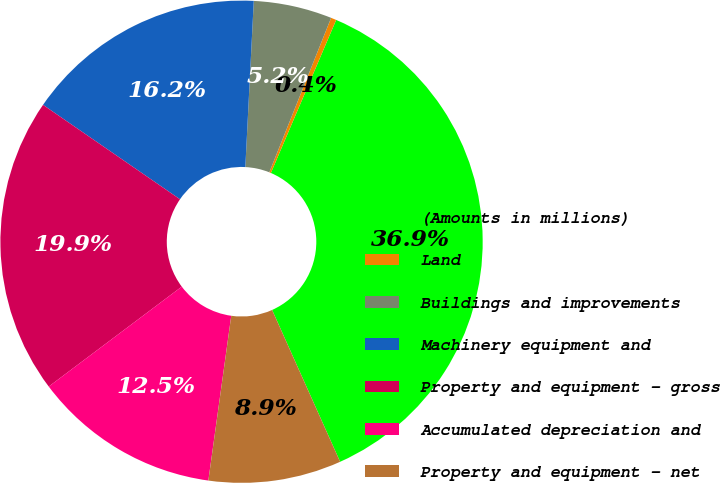Convert chart to OTSL. <chart><loc_0><loc_0><loc_500><loc_500><pie_chart><fcel>(Amounts in millions)<fcel>Land<fcel>Buildings and improvements<fcel>Machinery equipment and<fcel>Property and equipment - gross<fcel>Accumulated depreciation and<fcel>Property and equipment - net<nl><fcel>36.88%<fcel>0.36%<fcel>5.25%<fcel>16.2%<fcel>19.86%<fcel>12.55%<fcel>8.9%<nl></chart> 